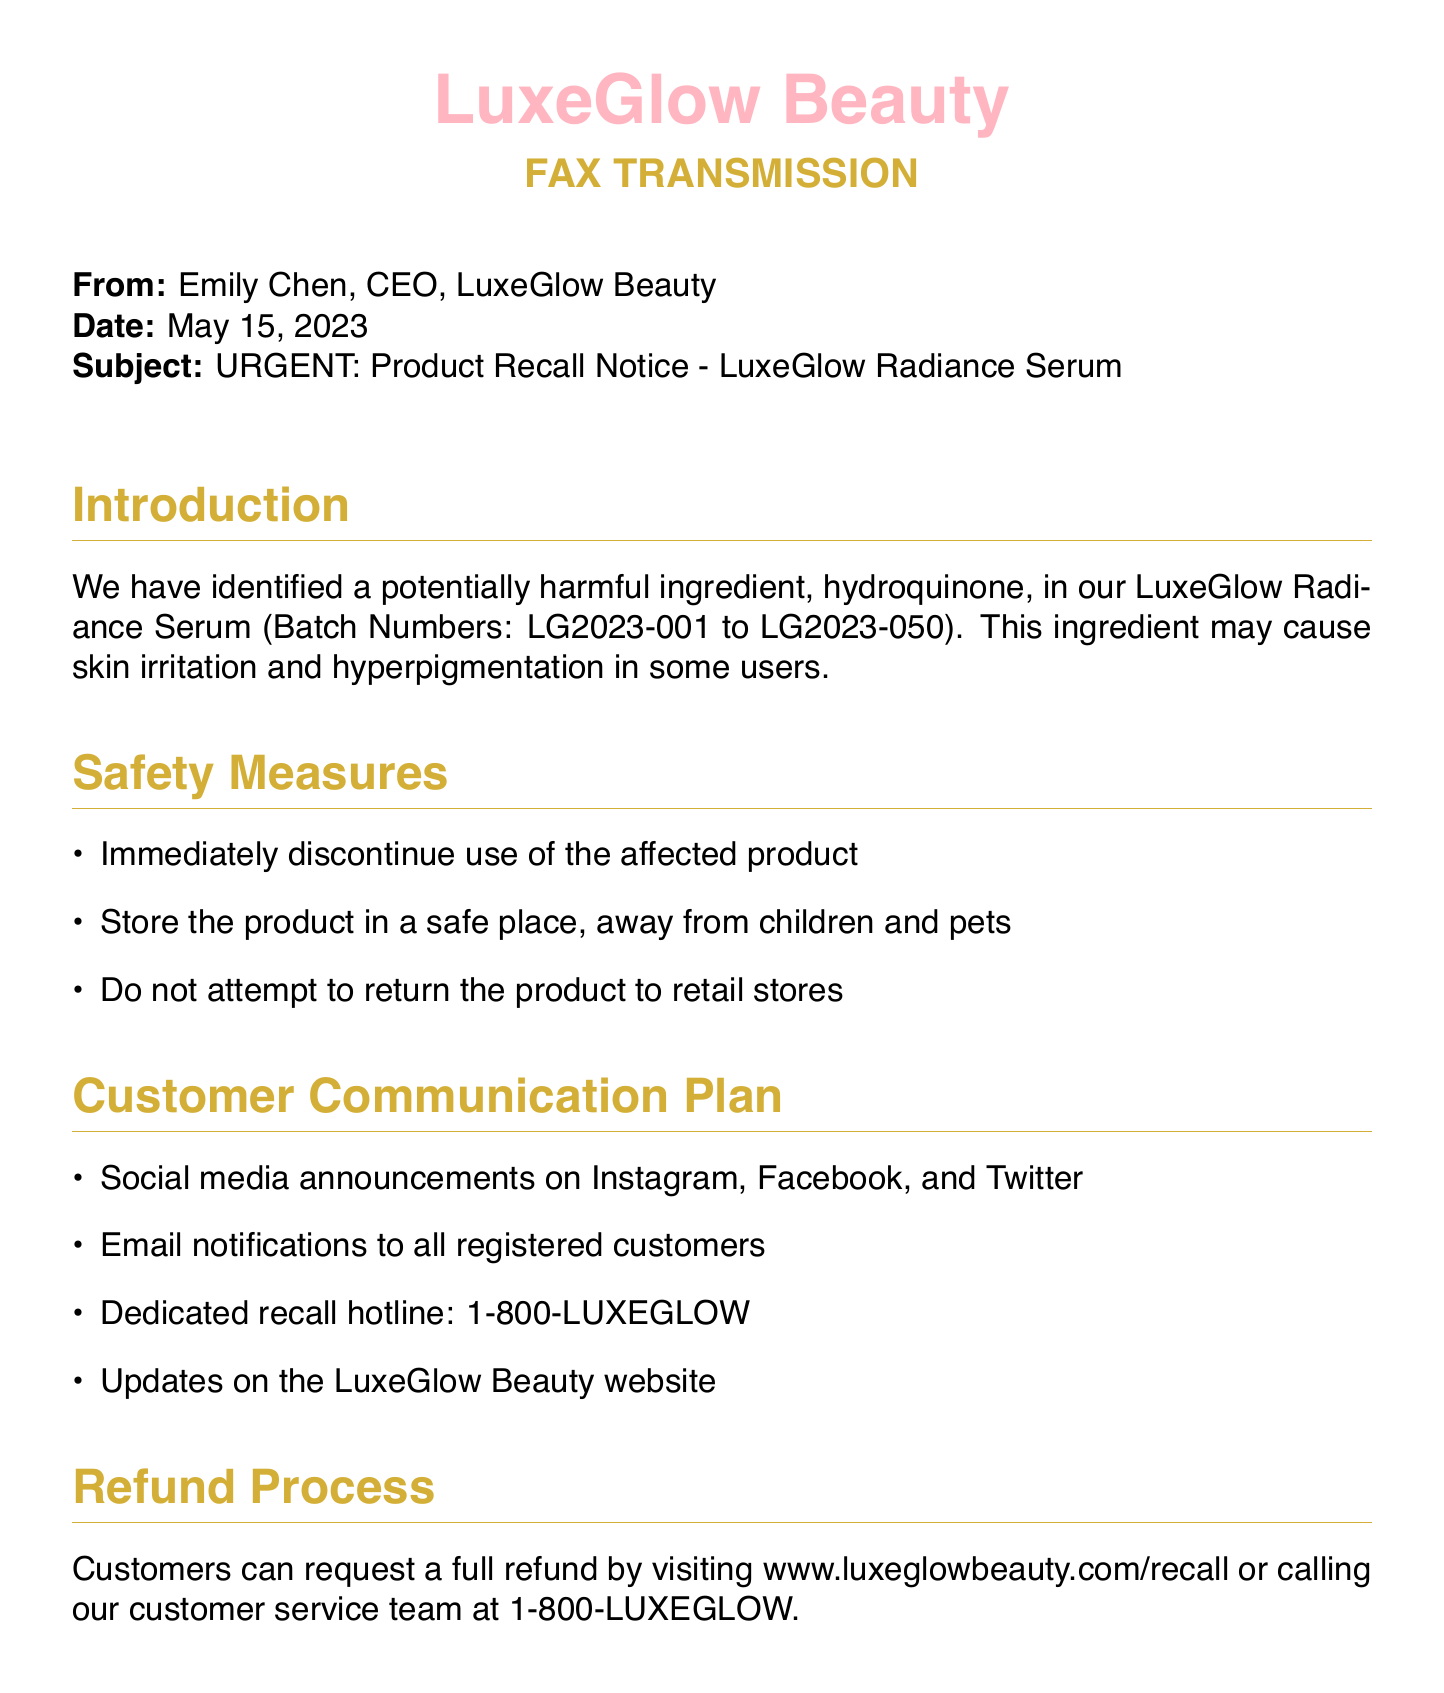What is the date of the fax? The date is provided in the document and is May 15, 2023.
Answer: May 15, 2023 Who is the sender of the fax? The sender is identified in the document as Emily Chen, the CEO of LuxeGlow Beauty.
Answer: Emily Chen What product is being recalled? The document specifies that the LuxeGlow Radiance Serum is being recalled.
Answer: LuxeGlow Radiance Serum What ingredient is causing the recall? The harmful ingredient mentioned in the document is hydroquinone.
Answer: hydroquinone What is the refund process website? The document provides a specific URL for the refund process as www.luxeglowbeauty.com/recall.
Answer: www.luxeglowbeauty.com/recall What is the dedicated recall hotline? The document states that the recall hotline number is 1-800-LUXEGLOW.
Answer: 1-800-LUXEGLOW What should customers do with the affected product? The safety measures advise customers to immediately discontinue use of the affected product.
Answer: Immediately discontinue use How will customers be notified about the recall? The notification plan includes social media announcements and email notifications to all registered customers.
Answer: Social media and email notifications What is the main apology expressed in the document? The document expresses an apology for any inconvenience or concern caused by the recall.
Answer: Apology for inconvenience or concern 